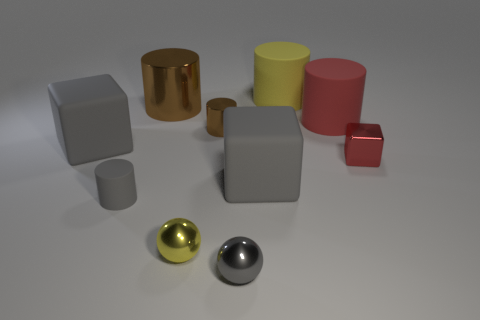Subtract all gray cubes. How many cubes are left? 1 Subtract all metallic cylinders. How many cylinders are left? 3 Subtract all spheres. How many objects are left? 8 Subtract 2 cylinders. How many cylinders are left? 3 Subtract all green cylinders. Subtract all blue cubes. How many cylinders are left? 5 Subtract all red balls. How many purple blocks are left? 0 Subtract all big cyan blocks. Subtract all large brown metallic cylinders. How many objects are left? 9 Add 7 big brown metal objects. How many big brown metal objects are left? 8 Add 7 tiny red balls. How many tiny red balls exist? 7 Subtract 0 brown blocks. How many objects are left? 10 